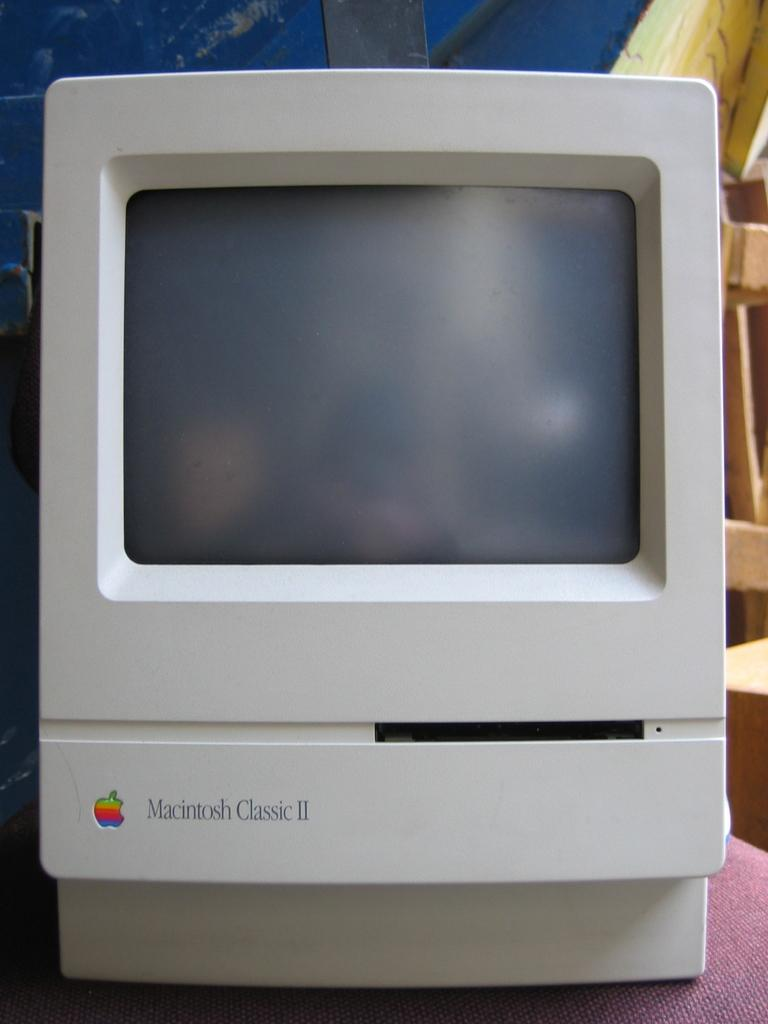Provide a one-sentence caption for the provided image. A fairly clean looking macintosh classic II fills the frame. 